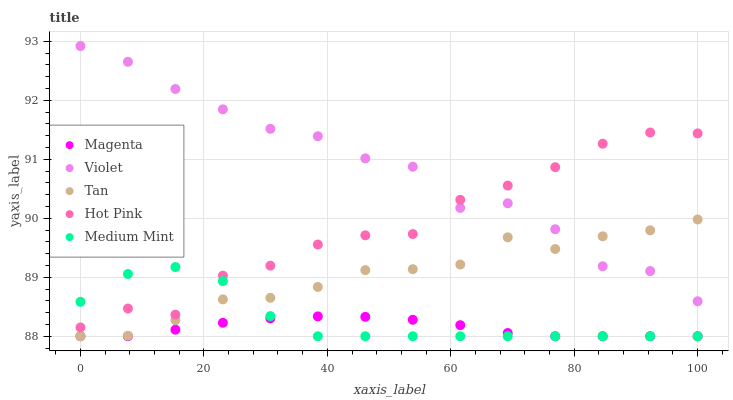Does Magenta have the minimum area under the curve?
Answer yes or no. Yes. Does Violet have the maximum area under the curve?
Answer yes or no. Yes. Does Hot Pink have the minimum area under the curve?
Answer yes or no. No. Does Hot Pink have the maximum area under the curve?
Answer yes or no. No. Is Magenta the smoothest?
Answer yes or no. Yes. Is Violet the roughest?
Answer yes or no. Yes. Is Hot Pink the smoothest?
Answer yes or no. No. Is Hot Pink the roughest?
Answer yes or no. No. Does Medium Mint have the lowest value?
Answer yes or no. Yes. Does Hot Pink have the lowest value?
Answer yes or no. No. Does Violet have the highest value?
Answer yes or no. Yes. Does Hot Pink have the highest value?
Answer yes or no. No. Is Tan less than Hot Pink?
Answer yes or no. Yes. Is Hot Pink greater than Tan?
Answer yes or no. Yes. Does Medium Mint intersect Tan?
Answer yes or no. Yes. Is Medium Mint less than Tan?
Answer yes or no. No. Is Medium Mint greater than Tan?
Answer yes or no. No. Does Tan intersect Hot Pink?
Answer yes or no. No. 